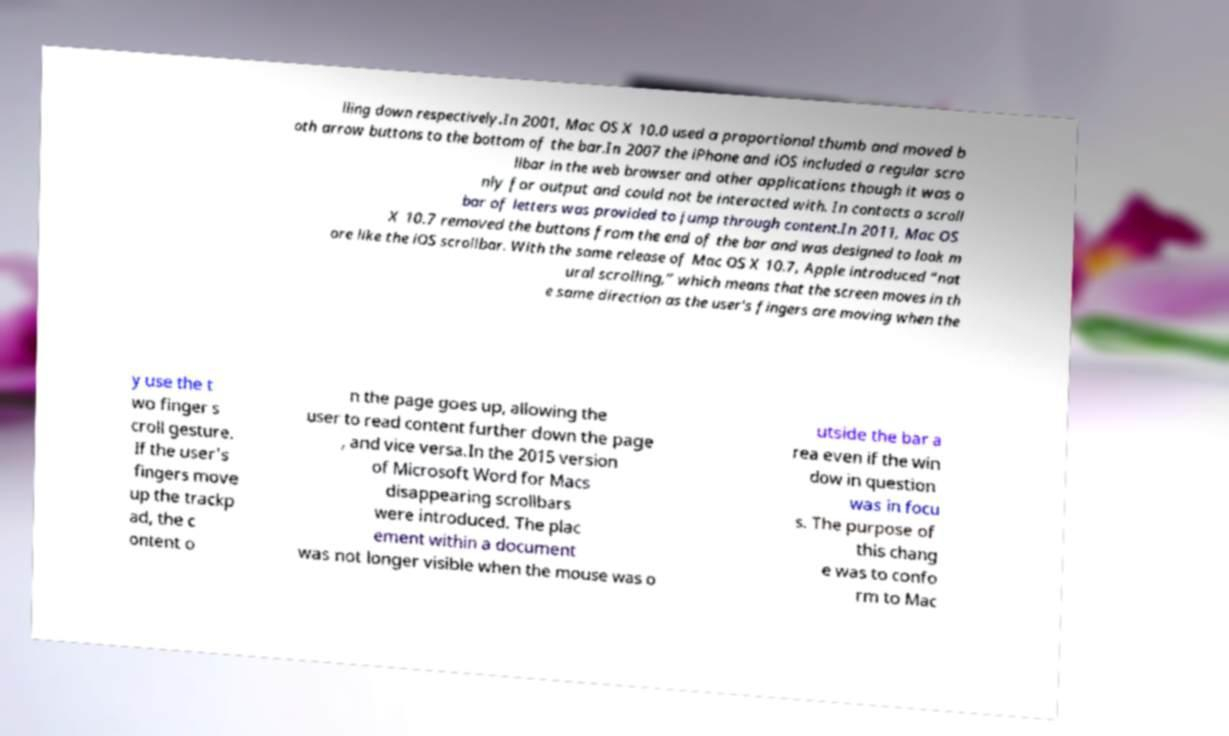There's text embedded in this image that I need extracted. Can you transcribe it verbatim? lling down respectively.In 2001, Mac OS X 10.0 used a proportional thumb and moved b oth arrow buttons to the bottom of the bar.In 2007 the iPhone and iOS included a regular scro llbar in the web browser and other applications though it was o nly for output and could not be interacted with. In contacts a scroll bar of letters was provided to jump through content.In 2011, Mac OS X 10.7 removed the buttons from the end of the bar and was designed to look m ore like the iOS scrollbar. With the same release of Mac OS X 10.7, Apple introduced “nat ural scrolling,” which means that the screen moves in th e same direction as the user's fingers are moving when the y use the t wo finger s croll gesture. If the user's fingers move up the trackp ad, the c ontent o n the page goes up, allowing the user to read content further down the page , and vice versa.In the 2015 version of Microsoft Word for Macs disappearing scrollbars were introduced. The plac ement within a document was not longer visible when the mouse was o utside the bar a rea even if the win dow in question was in focu s. The purpose of this chang e was to confo rm to Mac 